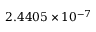Convert formula to latex. <formula><loc_0><loc_0><loc_500><loc_500>2 . 4 4 0 5 \times 1 0 ^ { - 7 }</formula> 